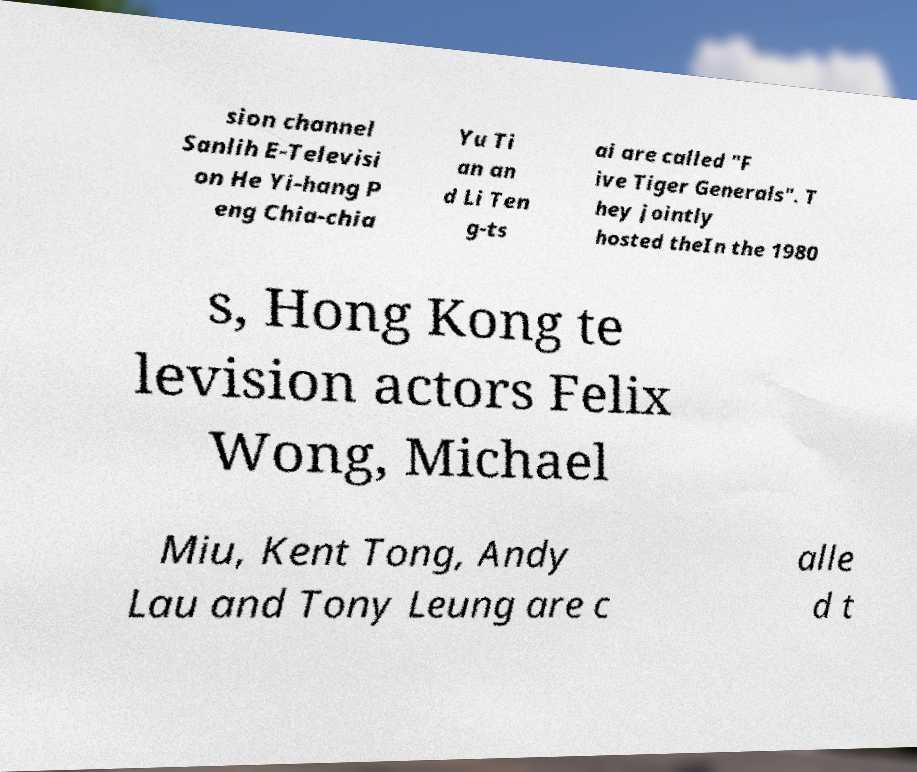I need the written content from this picture converted into text. Can you do that? sion channel Sanlih E-Televisi on He Yi-hang P eng Chia-chia Yu Ti an an d Li Ten g-ts ai are called "F ive Tiger Generals". T hey jointly hosted theIn the 1980 s, Hong Kong te levision actors Felix Wong, Michael Miu, Kent Tong, Andy Lau and Tony Leung are c alle d t 